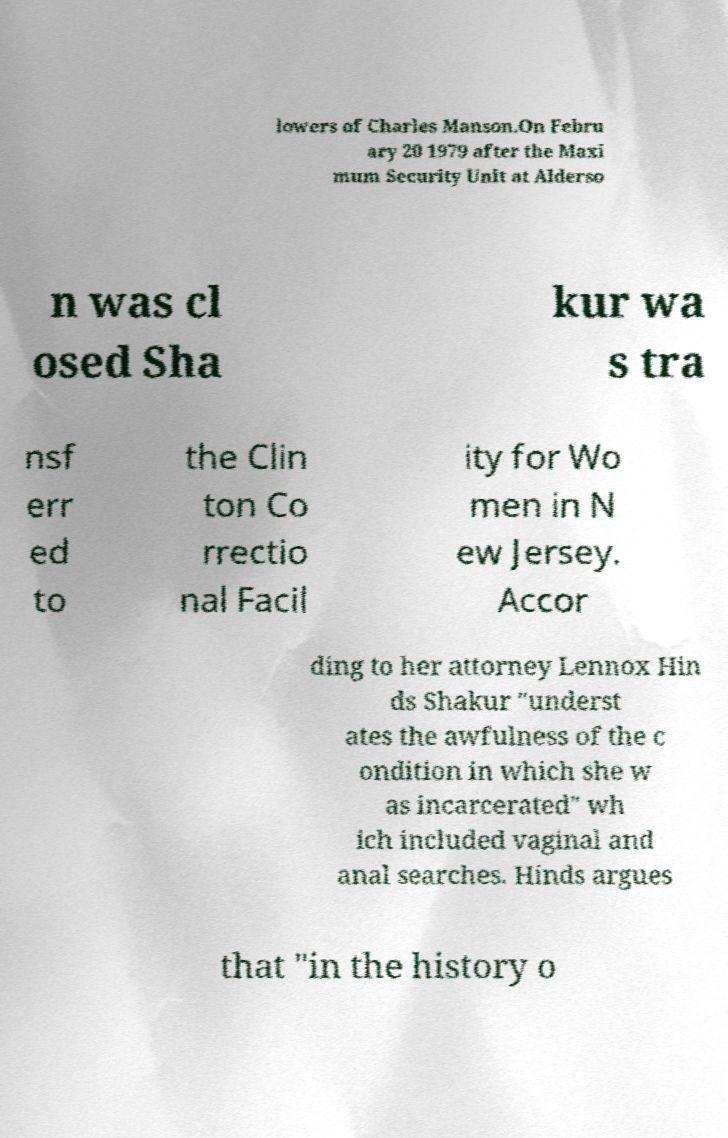Can you accurately transcribe the text from the provided image for me? lowers of Charles Manson.On Febru ary 20 1979 after the Maxi mum Security Unit at Alderso n was cl osed Sha kur wa s tra nsf err ed to the Clin ton Co rrectio nal Facil ity for Wo men in N ew Jersey. Accor ding to her attorney Lennox Hin ds Shakur "underst ates the awfulness of the c ondition in which she w as incarcerated" wh ich included vaginal and anal searches. Hinds argues that "in the history o 